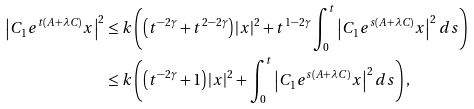<formula> <loc_0><loc_0><loc_500><loc_500>\left | C _ { 1 } e ^ { t \left ( A + \lambda C \right ) } x \right | ^ { 2 } & \leq k \left ( \left ( t ^ { - 2 \gamma } + t ^ { 2 - 2 \gamma } \right ) \left | x \right | ^ { 2 } + t ^ { 1 - 2 \gamma } \int _ { 0 } ^ { t } \left | C _ { 1 } e ^ { s \left ( A + \lambda C \right ) } x \right | ^ { 2 } d s \right ) \\ & \leq k \left ( \left ( t ^ { - 2 \gamma } + 1 \right ) \left | x \right | ^ { 2 } + \int _ { 0 } ^ { t } \left | C _ { 1 } e ^ { s \left ( A + \lambda C \right ) } x \right | ^ { 2 } d s \right ) ,</formula> 